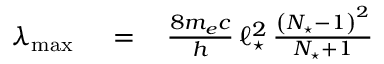<formula> <loc_0><loc_0><loc_500><loc_500>\begin{array} { r l r } { \lambda _ { \max } \, } & = } & { \, \frac { 8 m _ { e } c } { h } \, \ell _ { ^ { * } } ^ { 2 } \, \frac { \left ( N _ { ^ { * } } - 1 \right ) ^ { 2 } } { N _ { ^ { * } } + 1 } } \end{array}</formula> 